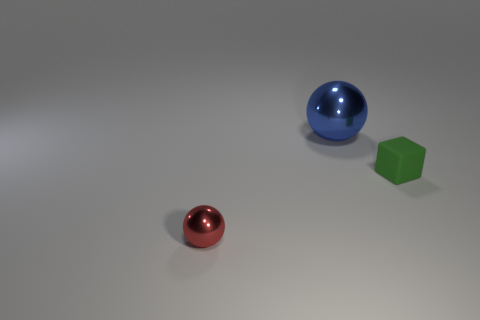Is there any other thing that is the same size as the blue metallic object?
Your response must be concise. No. How many other things are made of the same material as the large blue thing?
Ensure brevity in your answer.  1. What is the blue object made of?
Give a very brief answer. Metal. There is a sphere behind the cube; what size is it?
Your answer should be compact. Large. What number of big blue things are in front of the ball in front of the big ball?
Provide a short and direct response. 0. There is a metallic object in front of the blue sphere; does it have the same shape as the shiny thing behind the tiny green matte thing?
Give a very brief answer. Yes. How many things are right of the red metal object and to the left of the green matte thing?
Provide a short and direct response. 1. Is there a small rubber block that has the same color as the big object?
Give a very brief answer. No. There is a thing that is the same size as the matte block; what is its shape?
Ensure brevity in your answer.  Sphere. There is a tiny red sphere; are there any tiny cubes on the left side of it?
Ensure brevity in your answer.  No. 